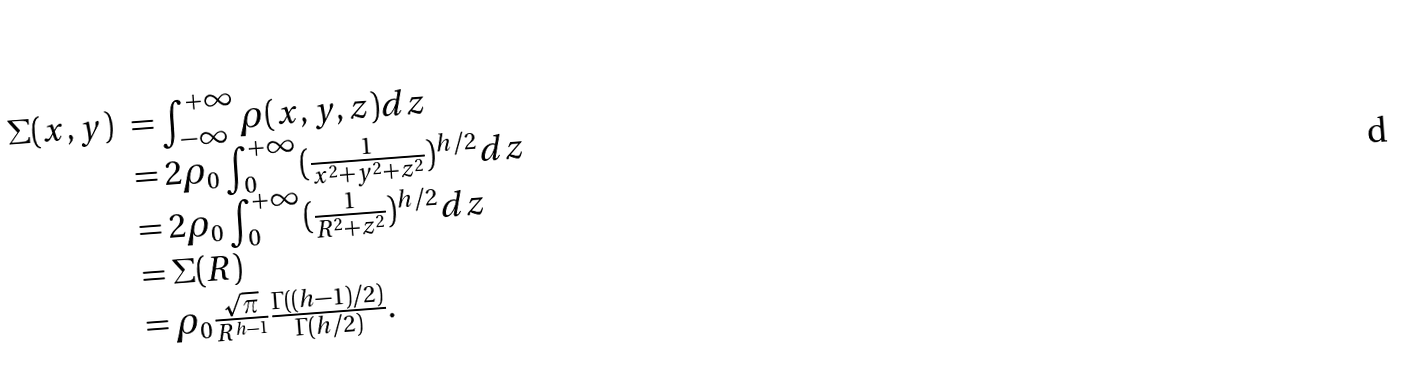Convert formula to latex. <formula><loc_0><loc_0><loc_500><loc_500>\begin{array} { l l } \Sigma ( x , y ) & = \int ^ { + \infty } _ { - \infty } \rho ( x , y , z ) d z \\ & = 2 \rho _ { 0 } \int ^ { + \infty } _ { 0 } ( \frac { 1 } { x ^ { 2 } + y ^ { 2 } + z ^ { 2 } } ) ^ { h / 2 } d z \\ & = 2 \rho _ { 0 } \int ^ { + \infty } _ { 0 } ( \frac { 1 } { R ^ { 2 } + z ^ { 2 } } ) ^ { h / 2 } d z \\ & = \Sigma ( R ) \\ & = \rho _ { 0 } \frac { \sqrt { \pi } } { R ^ { h - 1 } } \frac { \Gamma ( ( h - 1 ) / 2 ) } { \Gamma ( h / 2 ) } . \end{array}</formula> 